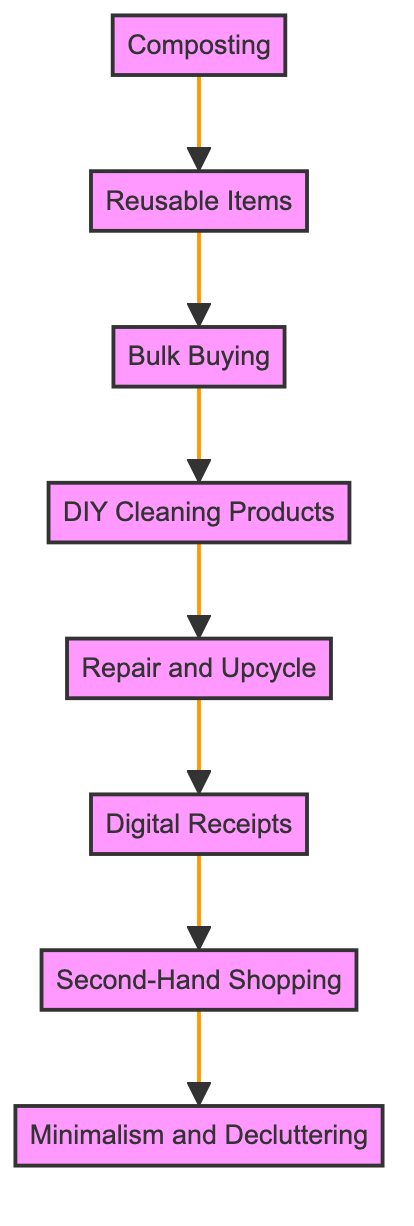What is the first step in the flow chart? The first step at the bottom of the flow chart is identified as "Minimalism and Decluttering," which indicates it is the initial action to take in the process of creating a zero-waste household.
Answer: Minimalism and Decluttering How many total steps are in the diagram? By counting each of the nodes listed in the flow chart, there are eight distinct steps contributing to the process outlined.
Answer: 8 What step comes directly before "Digital Receipts"? Tracing the flow upward, the step that precedes "Digital Receipts" is "Repair and Upcycle," as it is the immediate node above in the flow sequence.
Answer: Repair and Upcycle Which step follows "Bulk Buying"? Following "Bulk Buying" in the flow chart is the step "DIY Cleaning Products," indicating the next action after purchasing in bulk.
Answer: DIY Cleaning Products How does "Composting" relate to "Reusable Items"? In the flow, "Composting" is the initial step and leads directly to "Reusable Items" as the process flows upward; they are sequential steps in the efforts to reduce waste.
Answer: Sequential steps What are the last three steps in the flow chart? The last three steps, counted from the top down, are "Digital Receipts," "Repair and Upcycle," and "DIY Cleaning Products," representing the concluding actions before reaching the top node of "Minimalism and Decluttering."
Answer: Digital Receipts, Repair and Upcycle, DIY Cleaning Products Can you name the step located between "Second-Hand Shopping" and "Digital Receipts"? The step positioned between these two is "Repair and Upcycle," which provides a clear connection in the series of waste reduction actions denoted in the flow chart.
Answer: Repair and Upcycle Is "Second-Hand Shopping" directly connected to "Composting"? No, "Second-Hand Shopping" is not directly connected to "Composting" as they do not share an immediate upward or downward relationship; they are separated by multiple steps in the diagram.
Answer: No 